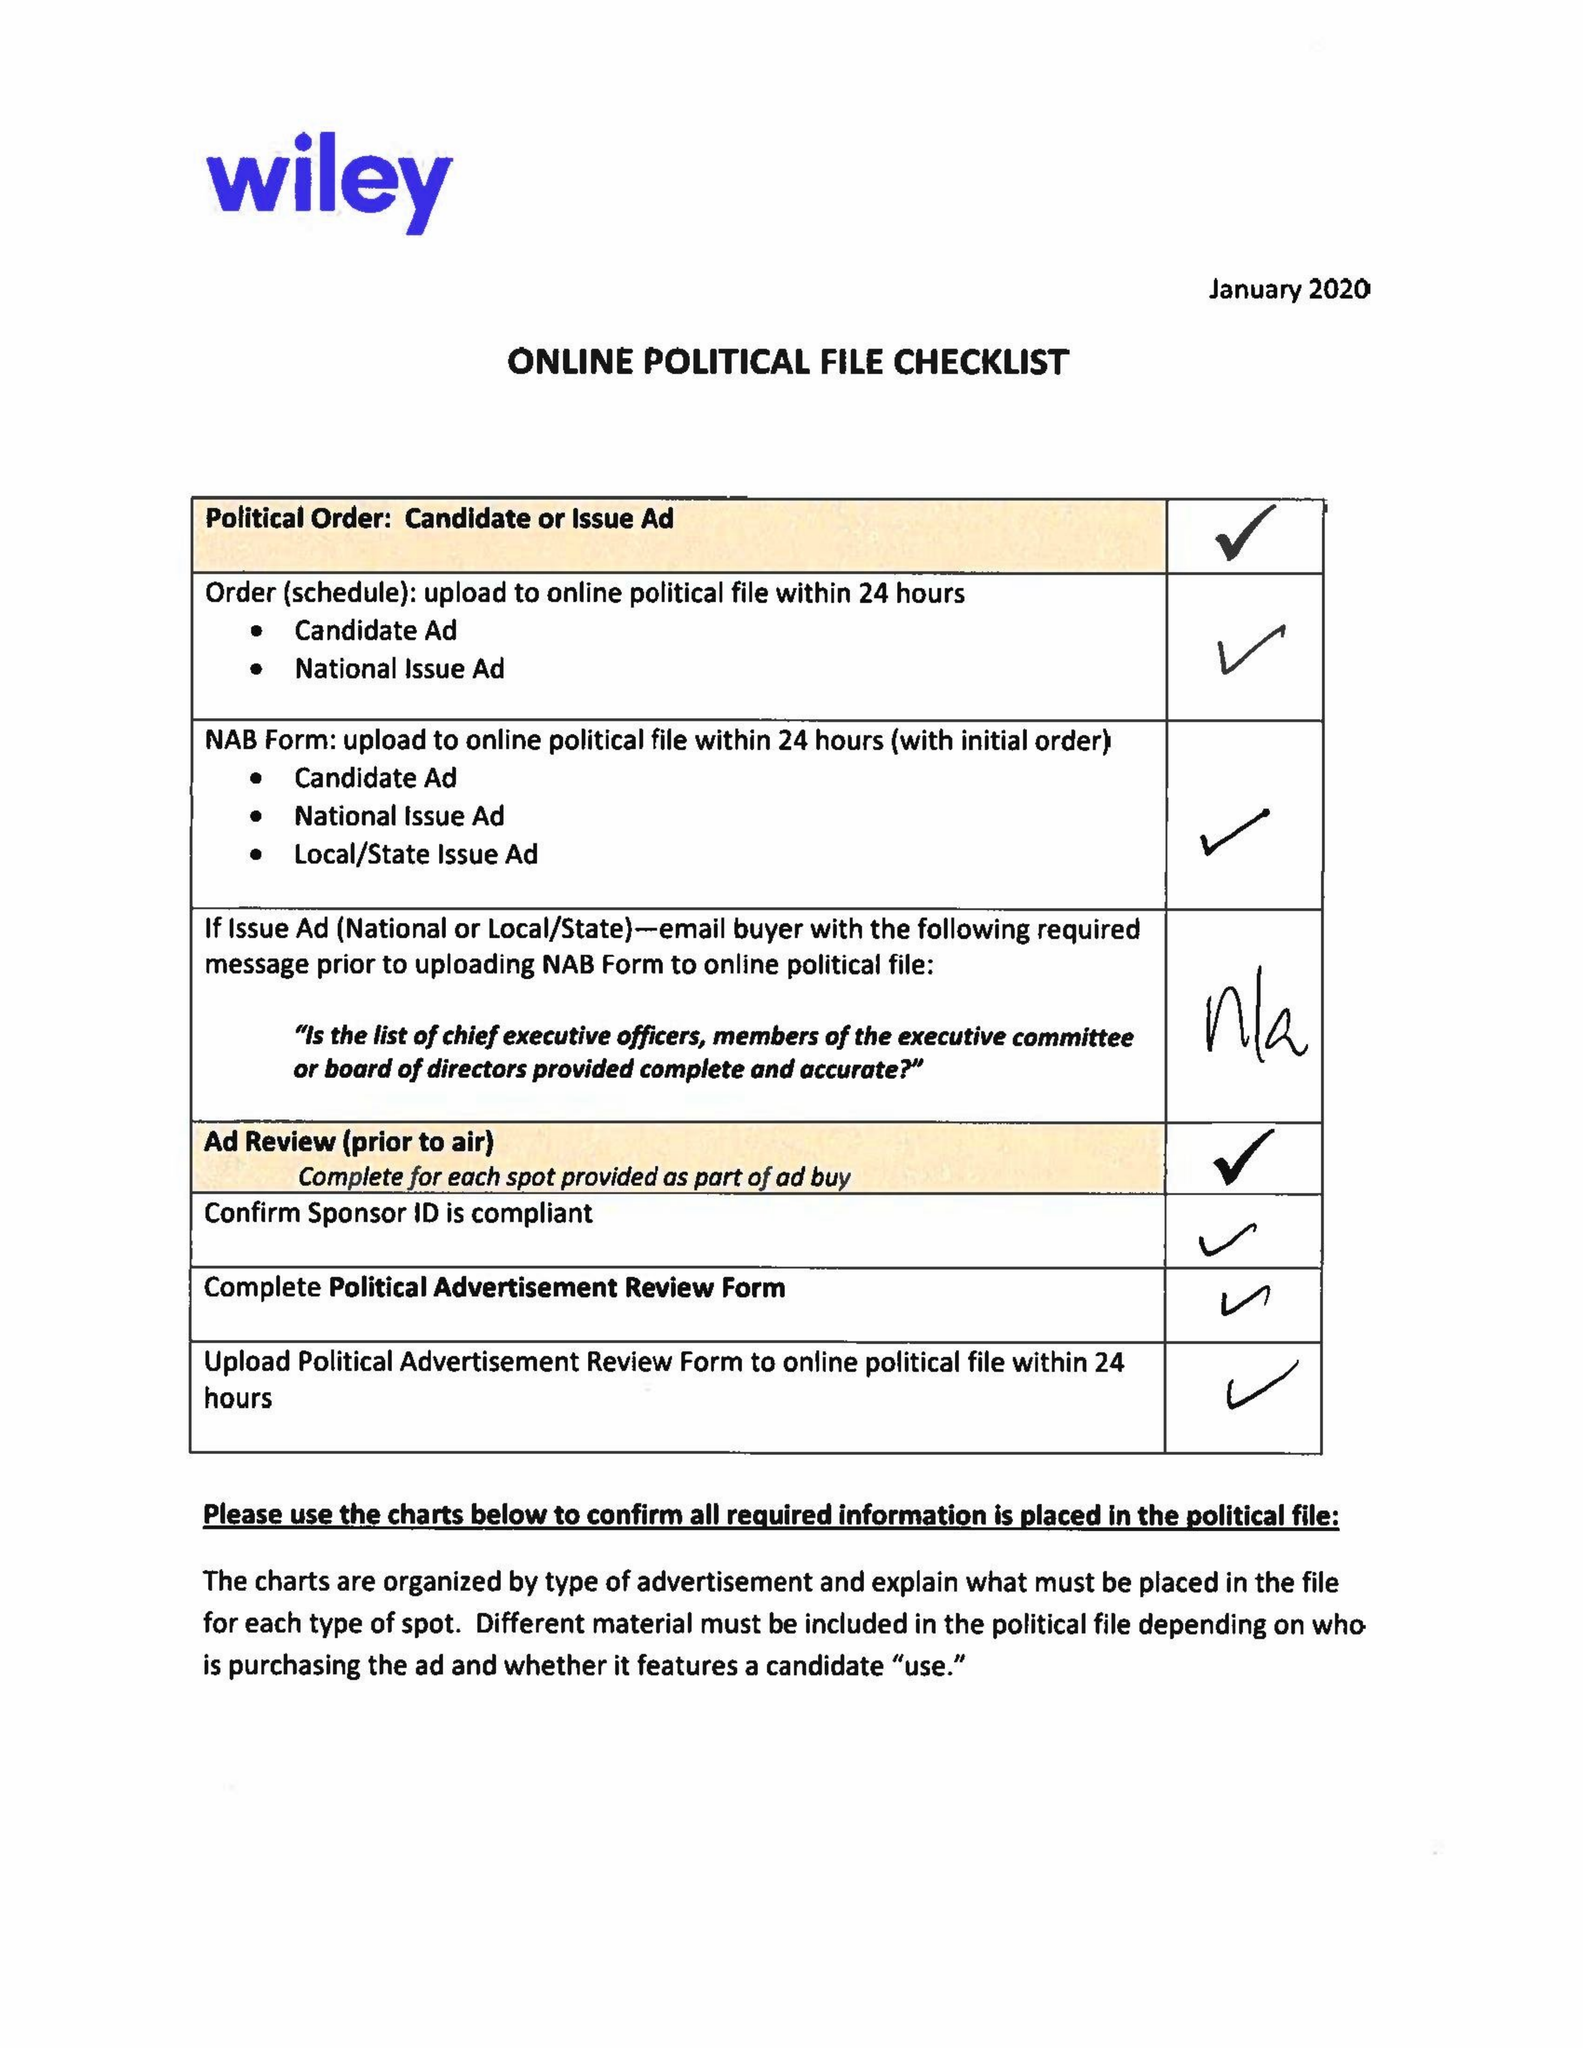What is the value for the gross_amount?
Answer the question using a single word or phrase. 22200.00 